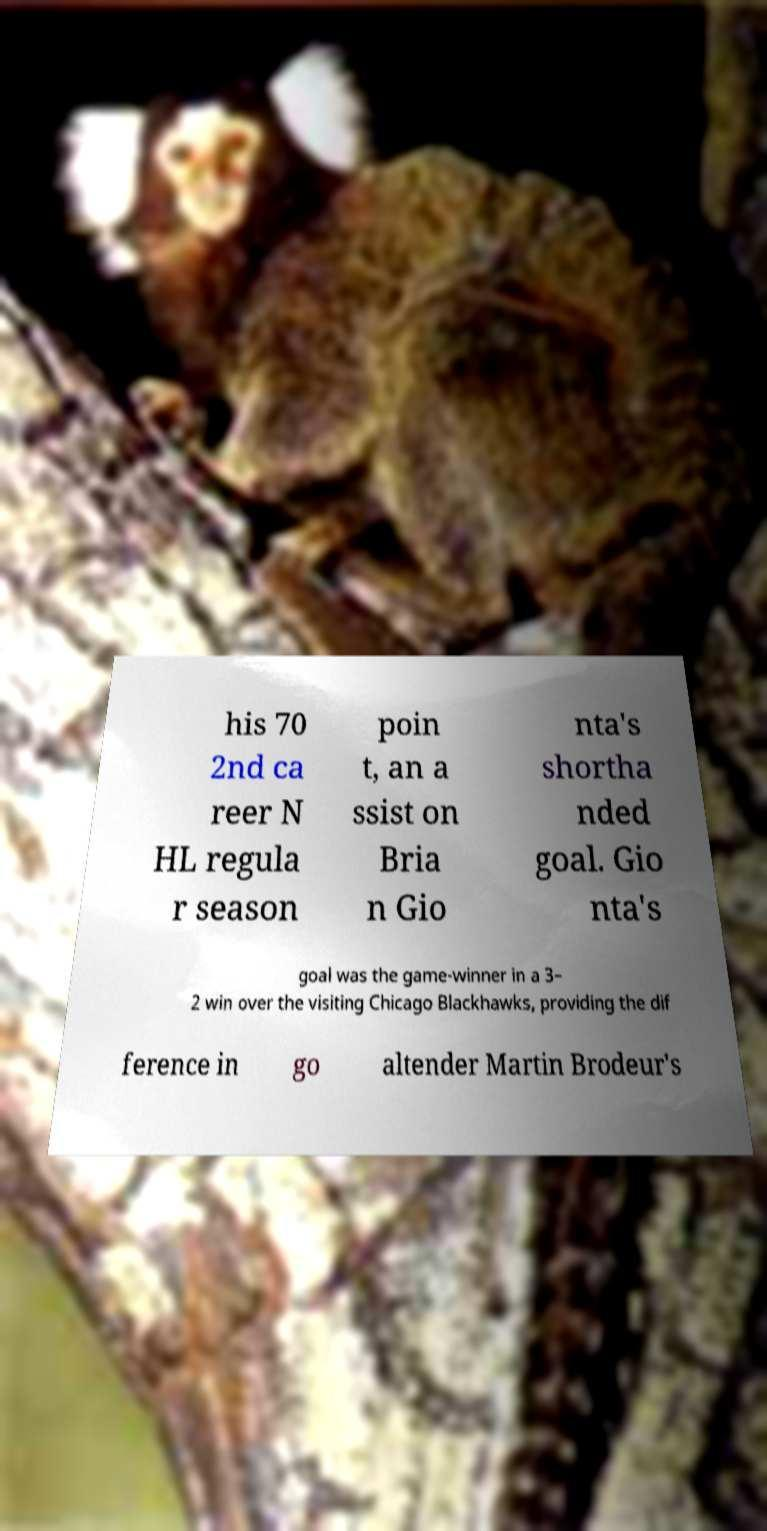There's text embedded in this image that I need extracted. Can you transcribe it verbatim? his 70 2nd ca reer N HL regula r season poin t, an a ssist on Bria n Gio nta's shortha nded goal. Gio nta's goal was the game-winner in a 3– 2 win over the visiting Chicago Blackhawks, providing the dif ference in go altender Martin Brodeur's 